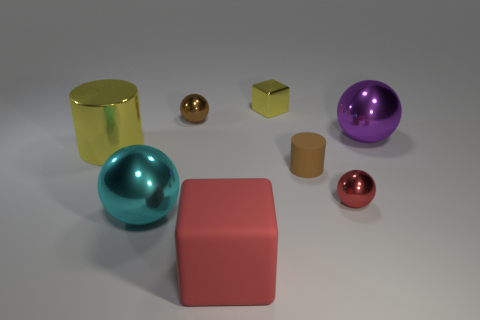There is a yellow shiny thing to the left of the brown ball; is it the same size as the purple ball?
Ensure brevity in your answer.  Yes. There is a yellow thing that is the same shape as the tiny brown rubber object; what material is it?
Provide a short and direct response. Metal. Does the tiny yellow metallic thing have the same shape as the cyan metal thing?
Give a very brief answer. No. There is a red thing that is behind the big cube; what number of small brown objects are behind it?
Your answer should be compact. 2. What is the shape of the red object that is made of the same material as the big yellow cylinder?
Provide a short and direct response. Sphere. How many purple objects are small rubber objects or shiny objects?
Provide a short and direct response. 1. Is there a large object in front of the large shiny ball behind the tiny sphere in front of the purple metal object?
Your answer should be compact. Yes. Are there fewer small red spheres than gray rubber blocks?
Your response must be concise. No. Do the red thing that is on the left side of the brown matte thing and the brown matte object have the same shape?
Provide a short and direct response. No. Are any large shiny cylinders visible?
Offer a terse response. Yes. 